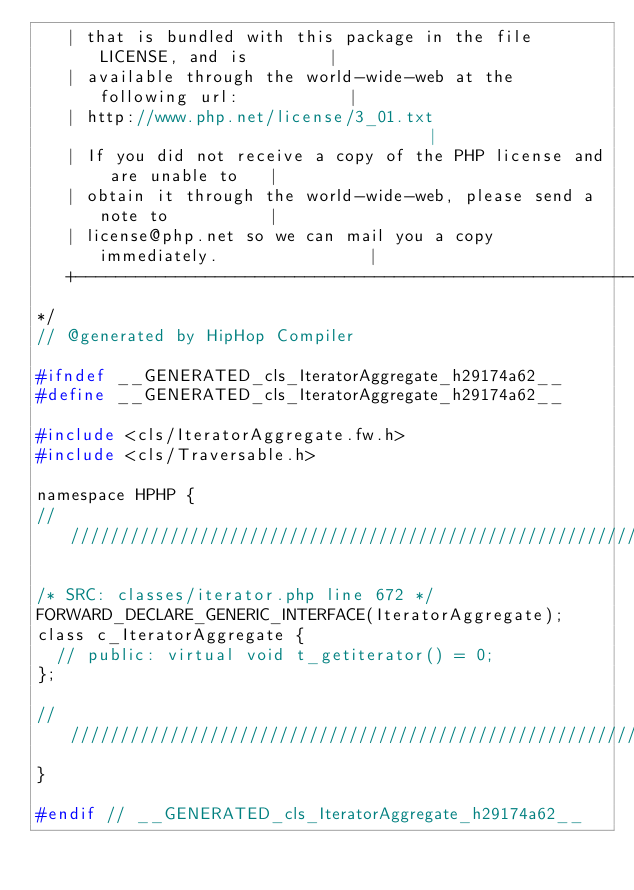<code> <loc_0><loc_0><loc_500><loc_500><_C_>   | that is bundled with this package in the file LICENSE, and is        |
   | available through the world-wide-web at the following url:           |
   | http://www.php.net/license/3_01.txt                                  |
   | If you did not receive a copy of the PHP license and are unable to   |
   | obtain it through the world-wide-web, please send a note to          |
   | license@php.net so we can mail you a copy immediately.               |
   +----------------------------------------------------------------------+
*/
// @generated by HipHop Compiler

#ifndef __GENERATED_cls_IteratorAggregate_h29174a62__
#define __GENERATED_cls_IteratorAggregate_h29174a62__

#include <cls/IteratorAggregate.fw.h>
#include <cls/Traversable.h>

namespace HPHP {
///////////////////////////////////////////////////////////////////////////////

/* SRC: classes/iterator.php line 672 */
FORWARD_DECLARE_GENERIC_INTERFACE(IteratorAggregate);
class c_IteratorAggregate {
  // public: virtual void t_getiterator() = 0;
};

///////////////////////////////////////////////////////////////////////////////
}

#endif // __GENERATED_cls_IteratorAggregate_h29174a62__
</code> 